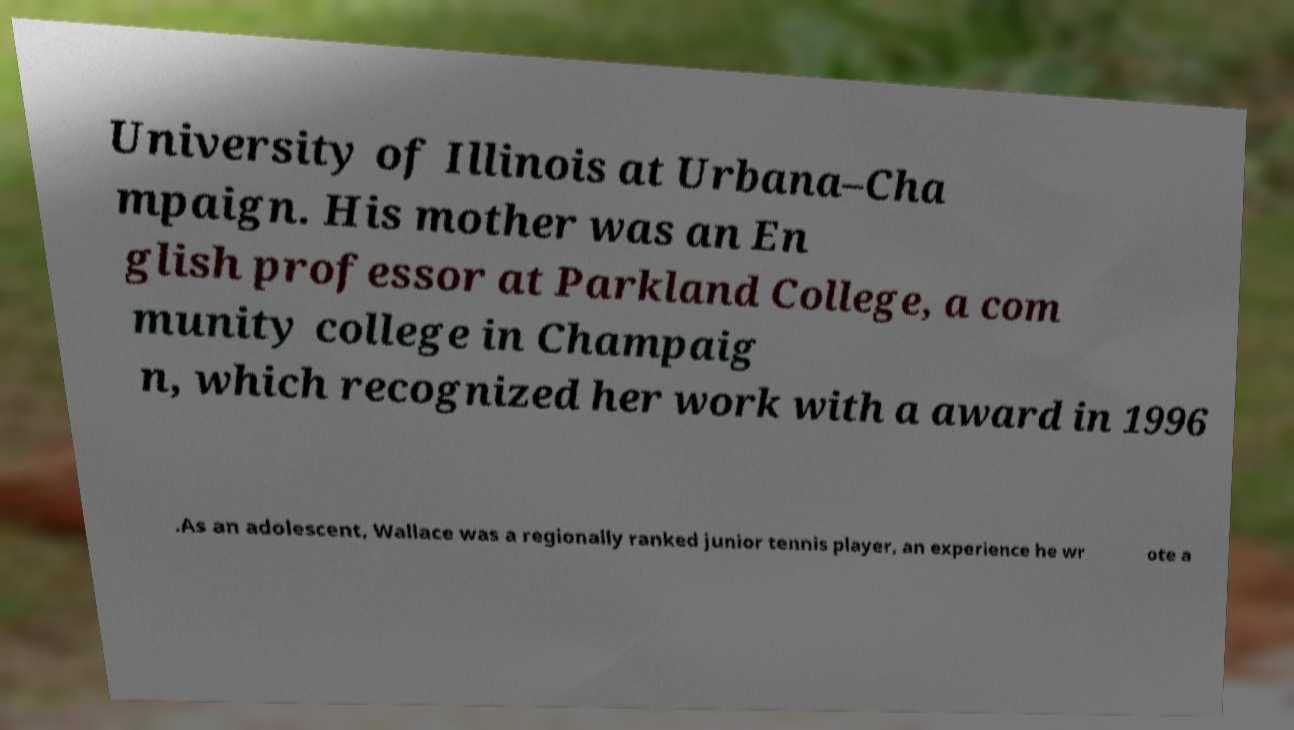Please read and relay the text visible in this image. What does it say? University of Illinois at Urbana–Cha mpaign. His mother was an En glish professor at Parkland College, a com munity college in Champaig n, which recognized her work with a award in 1996 .As an adolescent, Wallace was a regionally ranked junior tennis player, an experience he wr ote a 